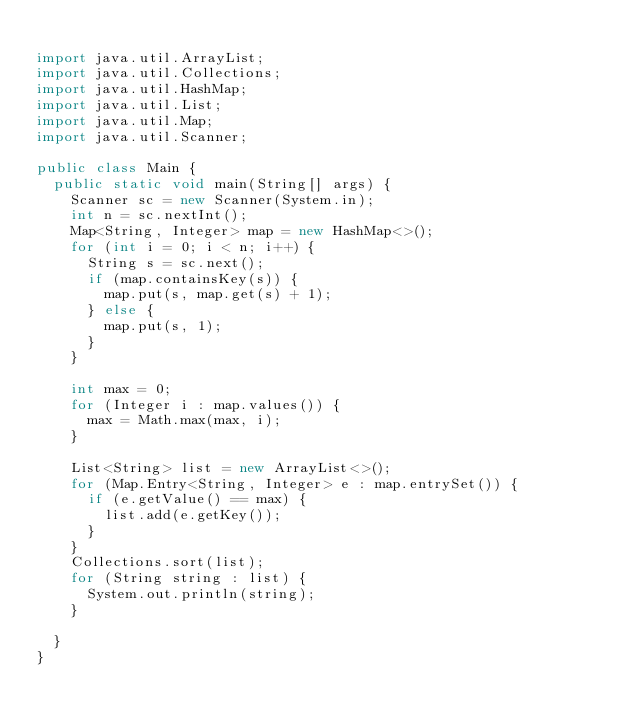<code> <loc_0><loc_0><loc_500><loc_500><_Java_>
import java.util.ArrayList;
import java.util.Collections;
import java.util.HashMap;
import java.util.List;
import java.util.Map;
import java.util.Scanner;

public class Main {
	public static void main(String[] args) {
		Scanner sc = new Scanner(System.in);
		int n = sc.nextInt();
		Map<String, Integer> map = new HashMap<>();
		for (int i = 0; i < n; i++) {
			String s = sc.next();
			if (map.containsKey(s)) {
				map.put(s, map.get(s) + 1);
			} else {
				map.put(s, 1);
			}
		}
		
		int max = 0;
		for (Integer i : map.values()) {
			max = Math.max(max, i);
		}
		
		List<String> list = new ArrayList<>();
		for (Map.Entry<String, Integer> e : map.entrySet()) {
			if (e.getValue() == max) {
				list.add(e.getKey());
			}
		}
		Collections.sort(list);
		for (String string : list) {
			System.out.println(string);
		}
		
	}
}


</code> 